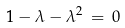<formula> <loc_0><loc_0><loc_500><loc_500>1 - \lambda - \lambda ^ { 2 } \, = \, 0</formula> 